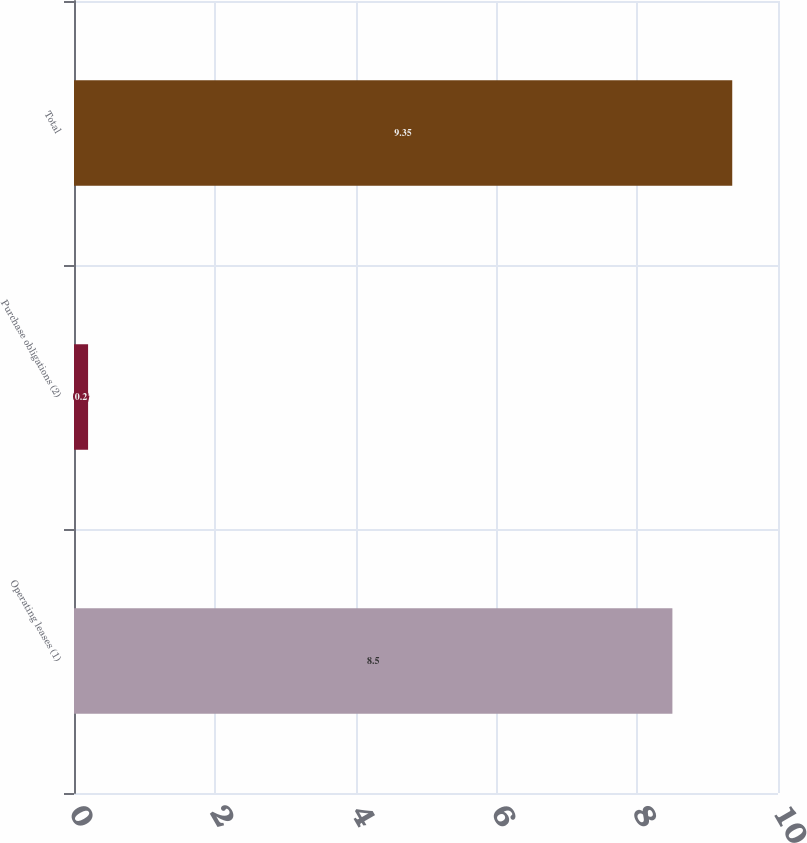<chart> <loc_0><loc_0><loc_500><loc_500><bar_chart><fcel>Operating leases (1)<fcel>Purchase obligations (2)<fcel>Total<nl><fcel>8.5<fcel>0.2<fcel>9.35<nl></chart> 